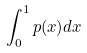<formula> <loc_0><loc_0><loc_500><loc_500>\int _ { 0 } ^ { 1 } p ( x ) d x</formula> 